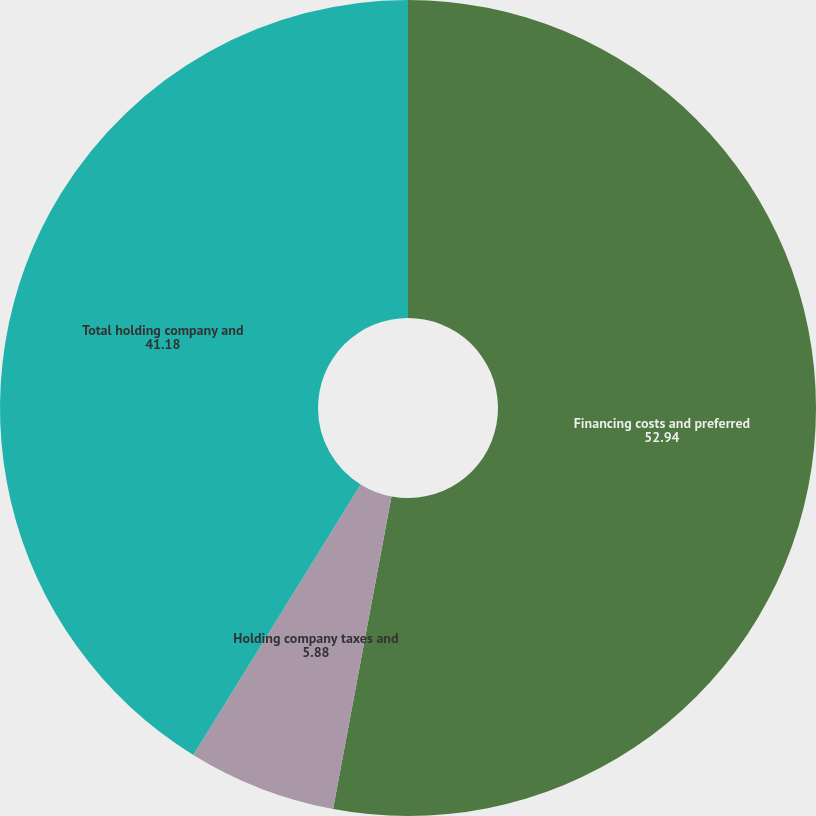Convert chart to OTSL. <chart><loc_0><loc_0><loc_500><loc_500><pie_chart><fcel>Financing costs and preferred<fcel>Holding company taxes and<fcel>Total holding company and<nl><fcel>52.94%<fcel>5.88%<fcel>41.18%<nl></chart> 